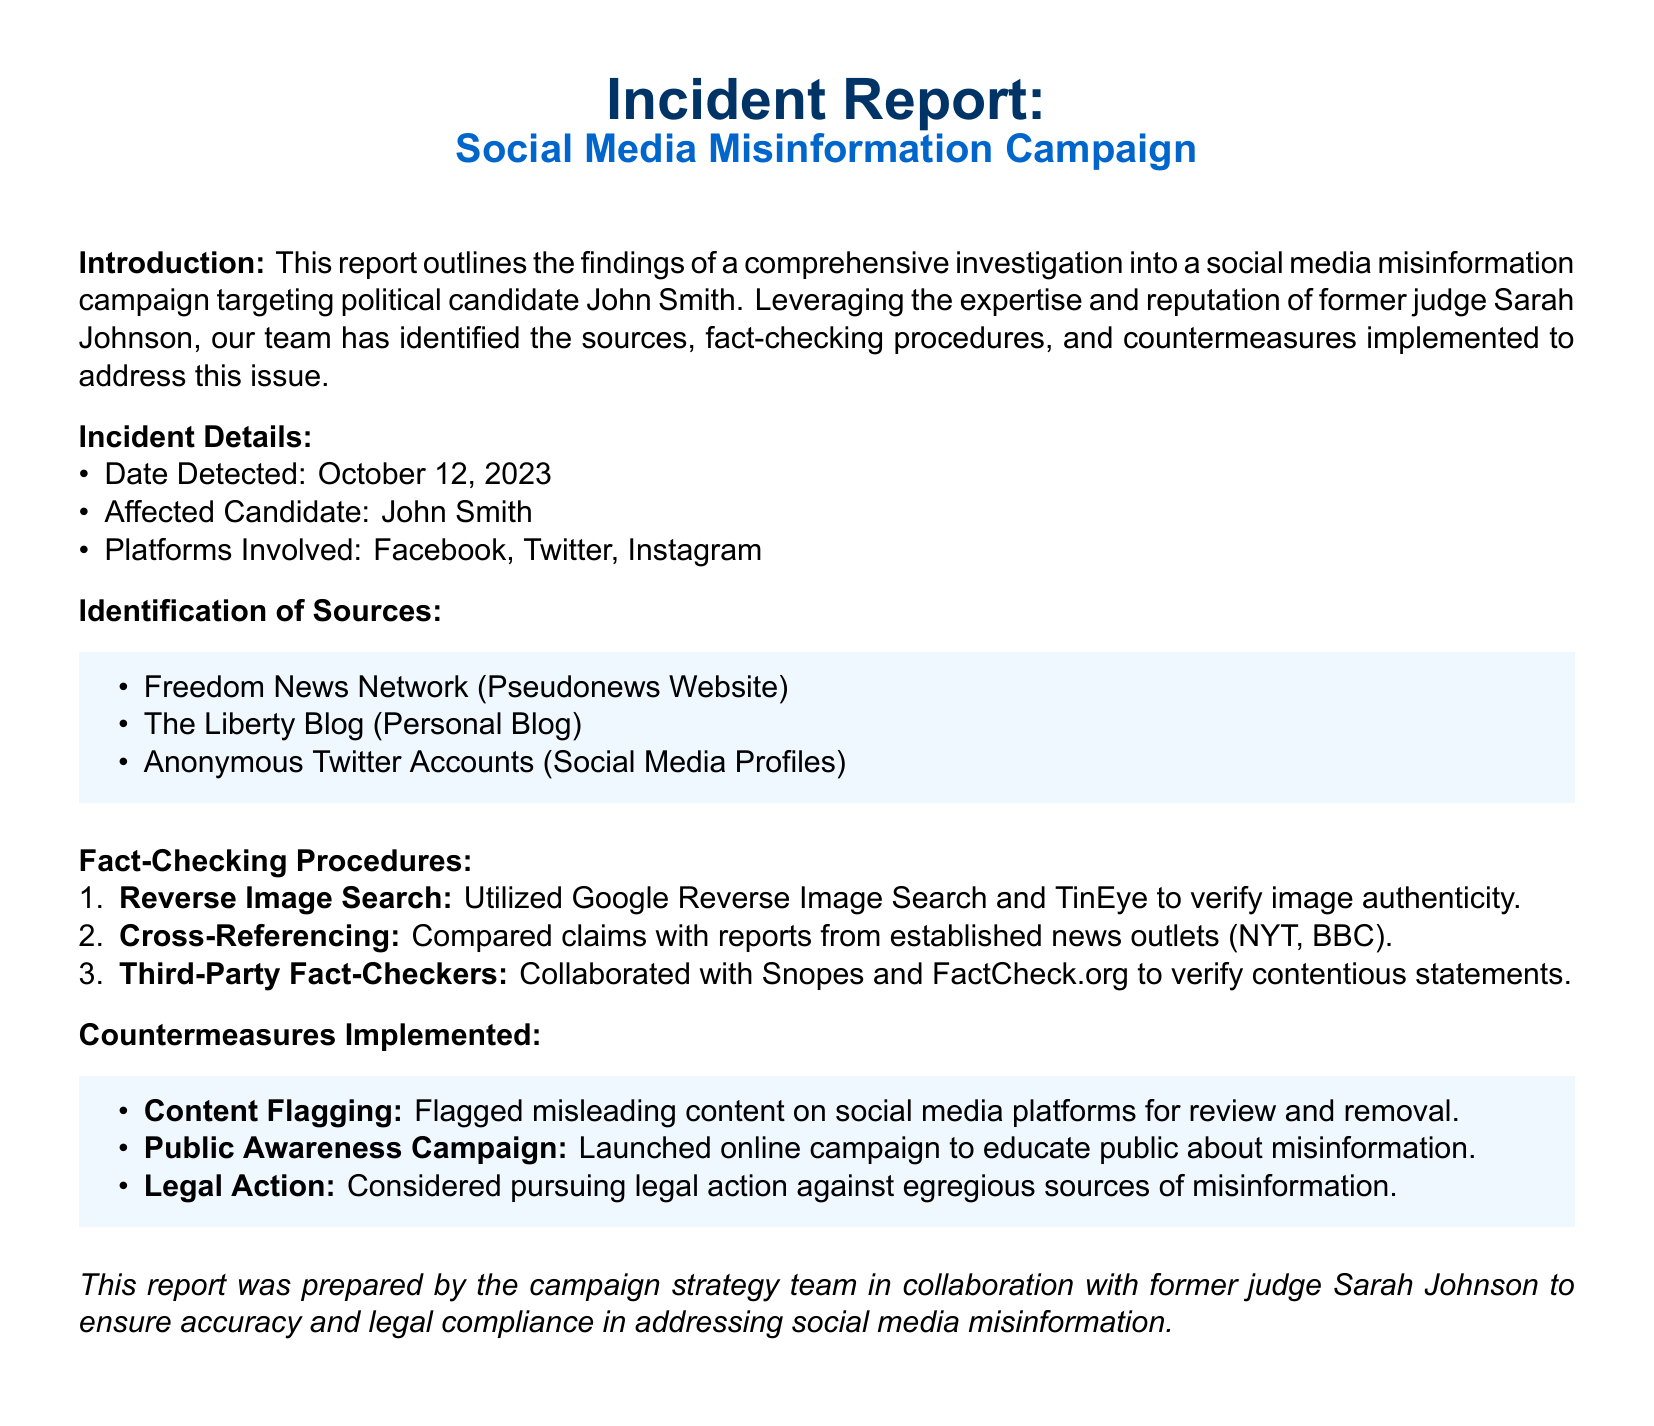What is the date detected? The date detected is specified in the document under the incident details section.
Answer: October 12, 2023 Who is the affected candidate? The affected candidate is mentioned in the incident details section of the report.
Answer: John Smith What platforms were involved in the misinformation campaign? The platforms involved are listed under the incident details in the document.
Answer: Facebook, Twitter, Instagram What is one of the sources identified in the report? Sources are specified in the identification of sources section, and one source is asked for.
Answer: Freedom News Network Which fact-checking procedure involves verifying image authenticity? The fact-checking procedures are outlined in a numbered format, and the specific procedure is being requested.
Answer: Reverse Image Search What type of campaign was launched to educate the public? The countermeasures implemented include a campaign, which is mentioned in the document.
Answer: Public Awareness Campaign How many types of fact-checking procedures are mentioned? The fact-checking procedures are listed numerically, and the count is being asked for.
Answer: Three What action is considered against egregious sources of misinformation? The possible action regarding misinformation sources is described in the countermeasures implemented section of the report.
Answer: Legal Action What collaboration was established for fact-checking? The document specifies organizations that were involved in fact-checking, leading to this query.
Answer: Snopes and FactCheck.org 